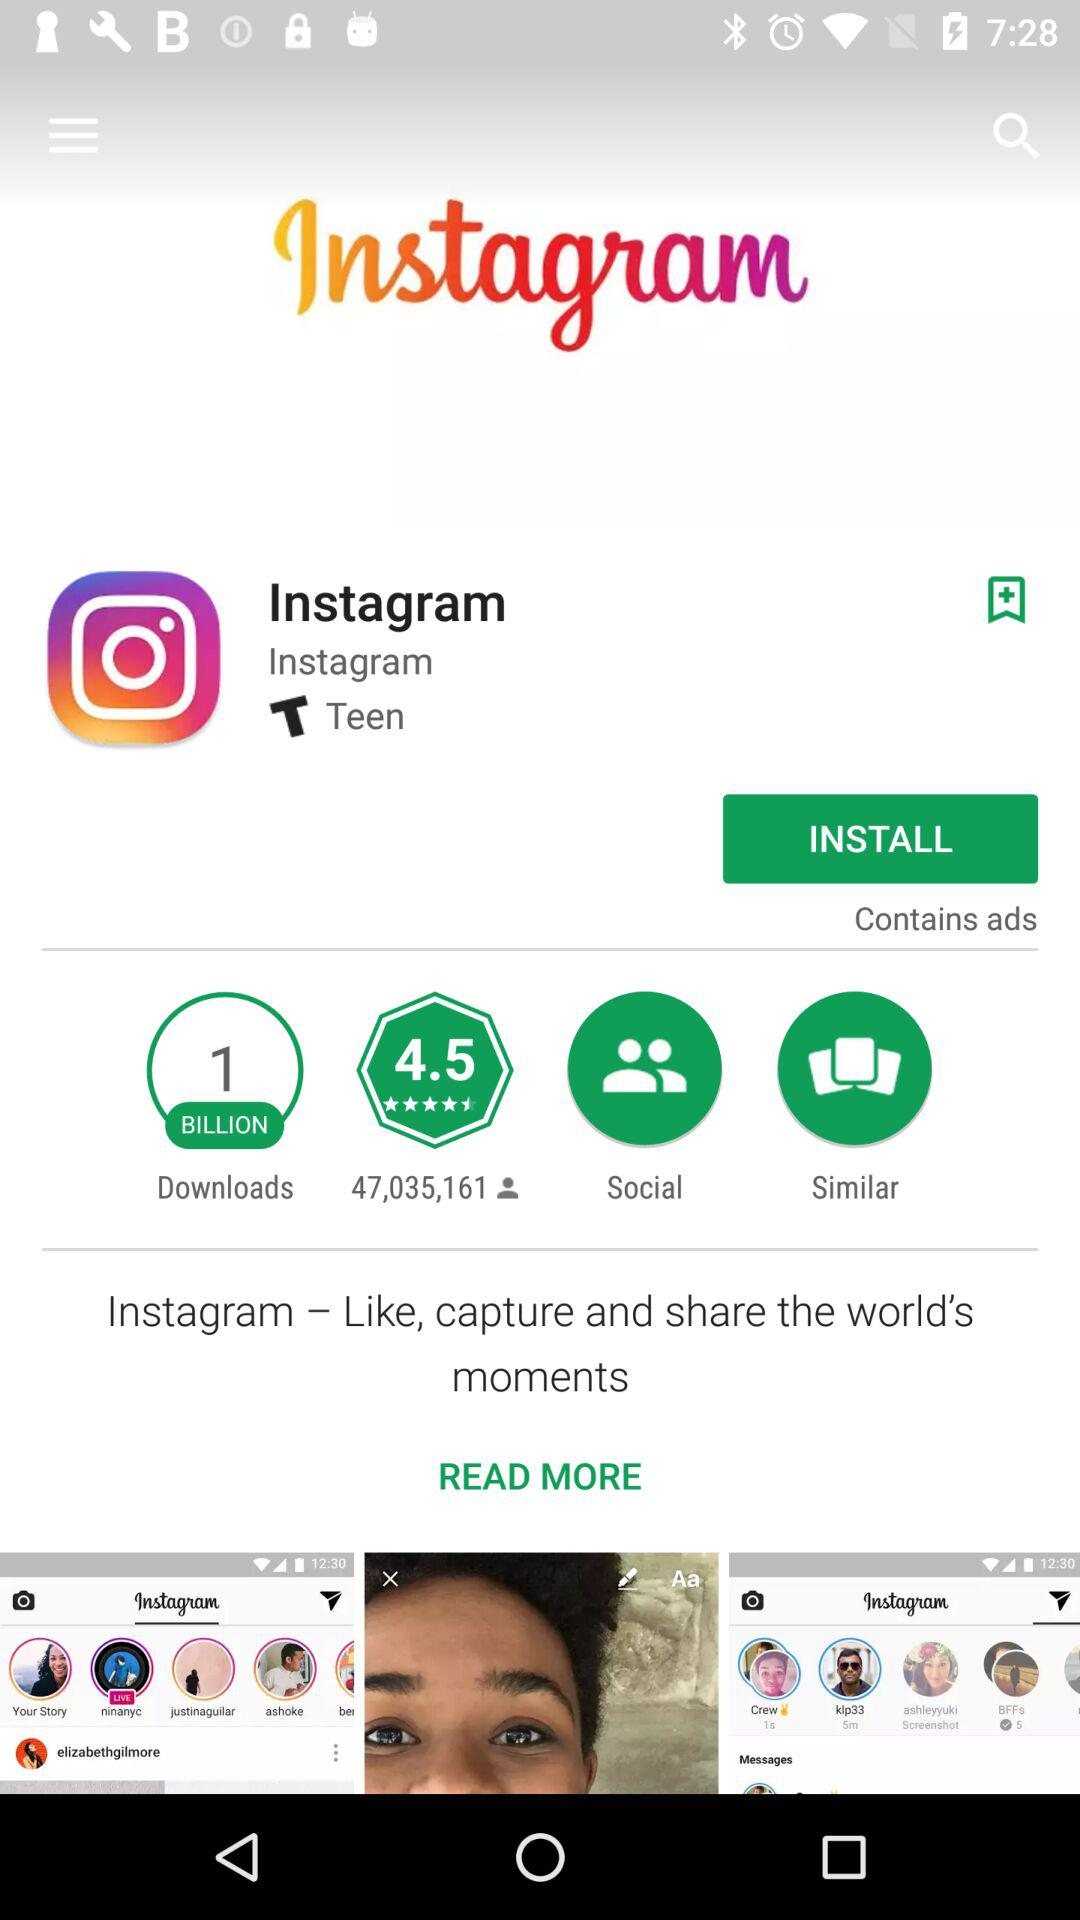What is the rating out of 5? The rating out of 5 is 4.5. 